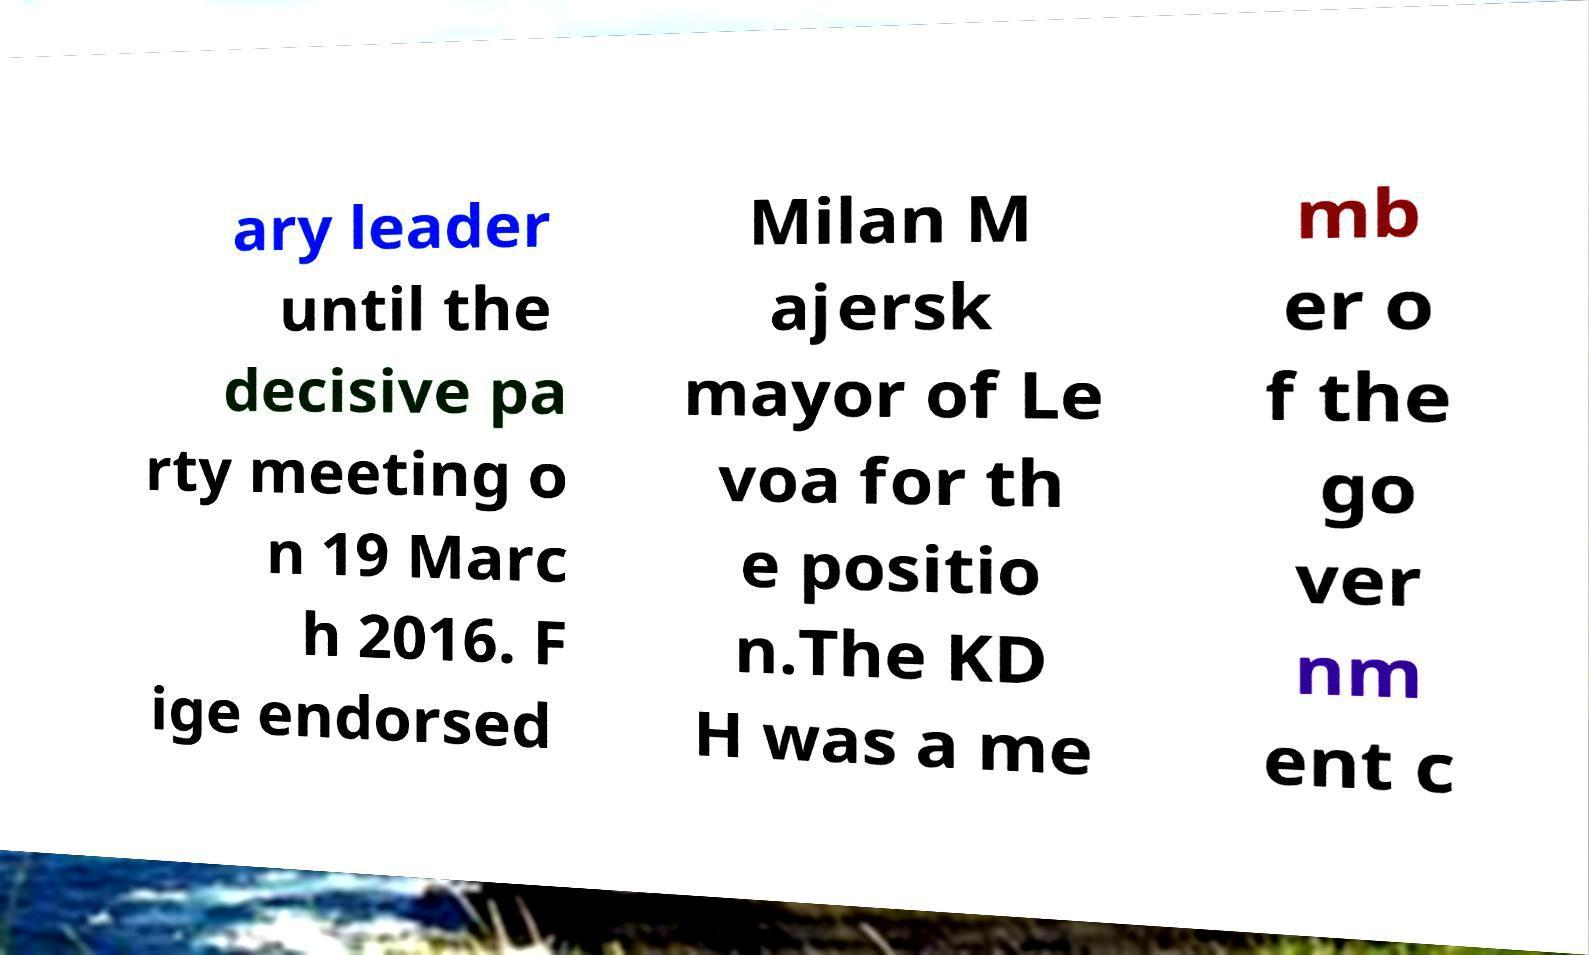What messages or text are displayed in this image? I need them in a readable, typed format. ary leader until the decisive pa rty meeting o n 19 Marc h 2016. F ige endorsed Milan M ajersk mayor of Le voa for th e positio n.The KD H was a me mb er o f the go ver nm ent c 